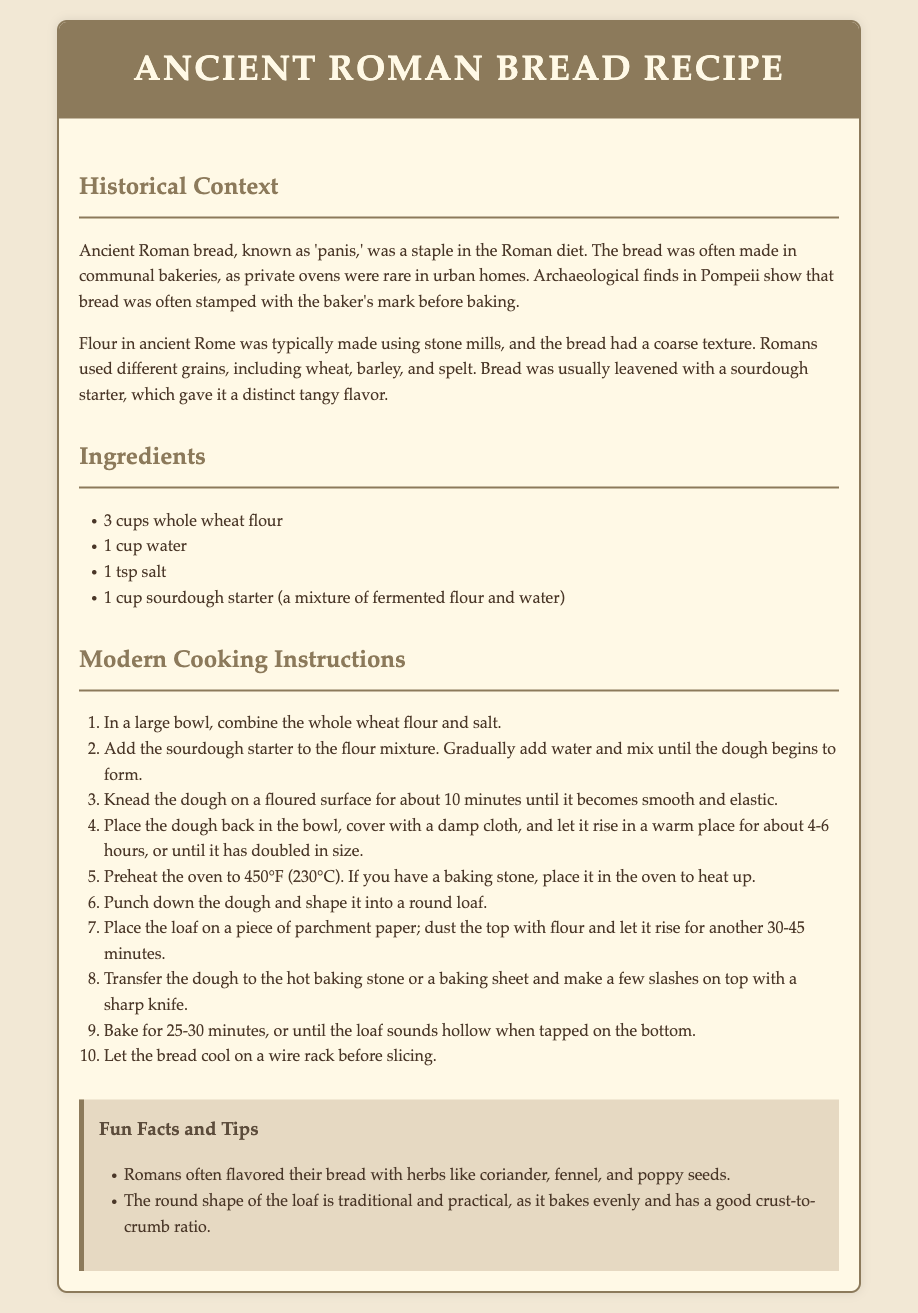what is the main ingredient in the Ancient Roman bread? The main ingredient listed is whole wheat flour, which is essential for making the bread.
Answer: whole wheat flour how many cups of water are needed for the recipe? The recipe specifies the need for 1 cup of water to be added to the ingredients.
Answer: 1 cup what is the rising time for the dough? The dough should rise in a warm place for about 4-6 hours until it has doubled in size, as stated in the instructions.
Answer: 4-6 hours what historical find indicates the use of baker's stamps? The document mentions archaeological finds in Pompeii where bread was often stamped with the baker's mark before baking.
Answer: Pompeii which grains were used in Ancient Roman bread? The document states that Romans used different grains, including wheat, barley, and spelt for their bread.
Answer: wheat, barley, and spelt what is the baking temperature for the Ancient Roman bread? The modern cooking instructions specify that the oven should be preheated to 450°F (230°C) for baking.
Answer: 450°F (230°C) what is used to flavor Ancient Roman bread? The recipe mentions that Romans often flavored their bread with herbs, which are listed as specific spices in the fun facts section.
Answer: herbs what is a recommended tool for baking? According to the instructions, if available, a baking stone is recommended to be placed in the oven to heat up.
Answer: baking stone how long should the bread bake? The baking duration for the Ancient Roman bread is specified as 25-30 minutes in the cooking instructions.
Answer: 25-30 minutes 